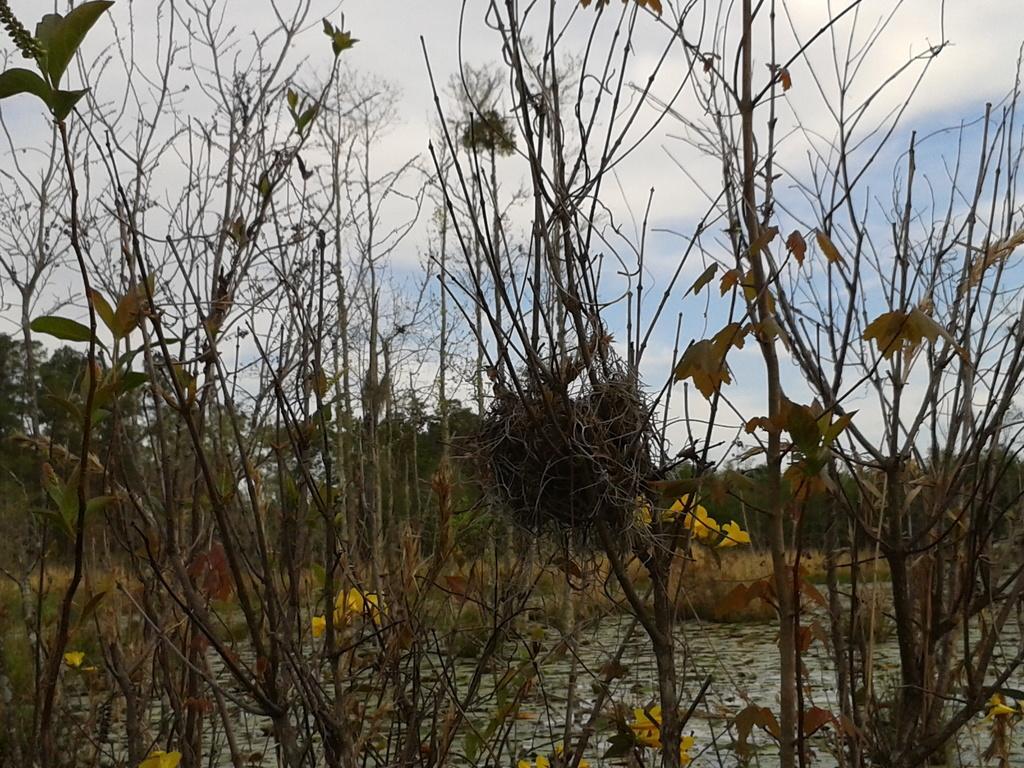How would you summarize this image in a sentence or two? In this picture we see a place with dry plants, bushes and trees. Here the sky is blue. 